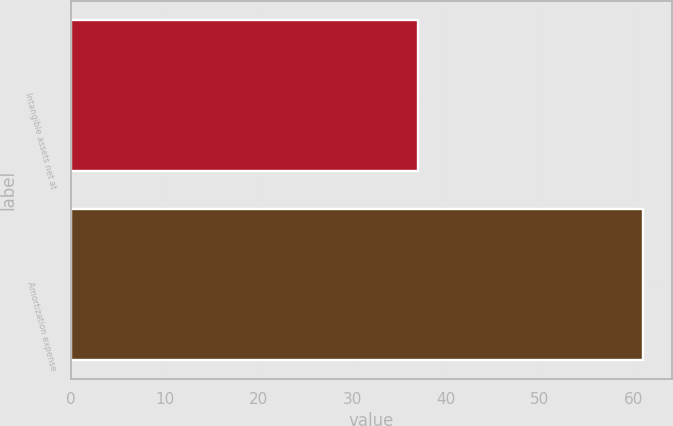Convert chart. <chart><loc_0><loc_0><loc_500><loc_500><bar_chart><fcel>Intangible assets net at<fcel>Amortization expense<nl><fcel>37<fcel>61<nl></chart> 